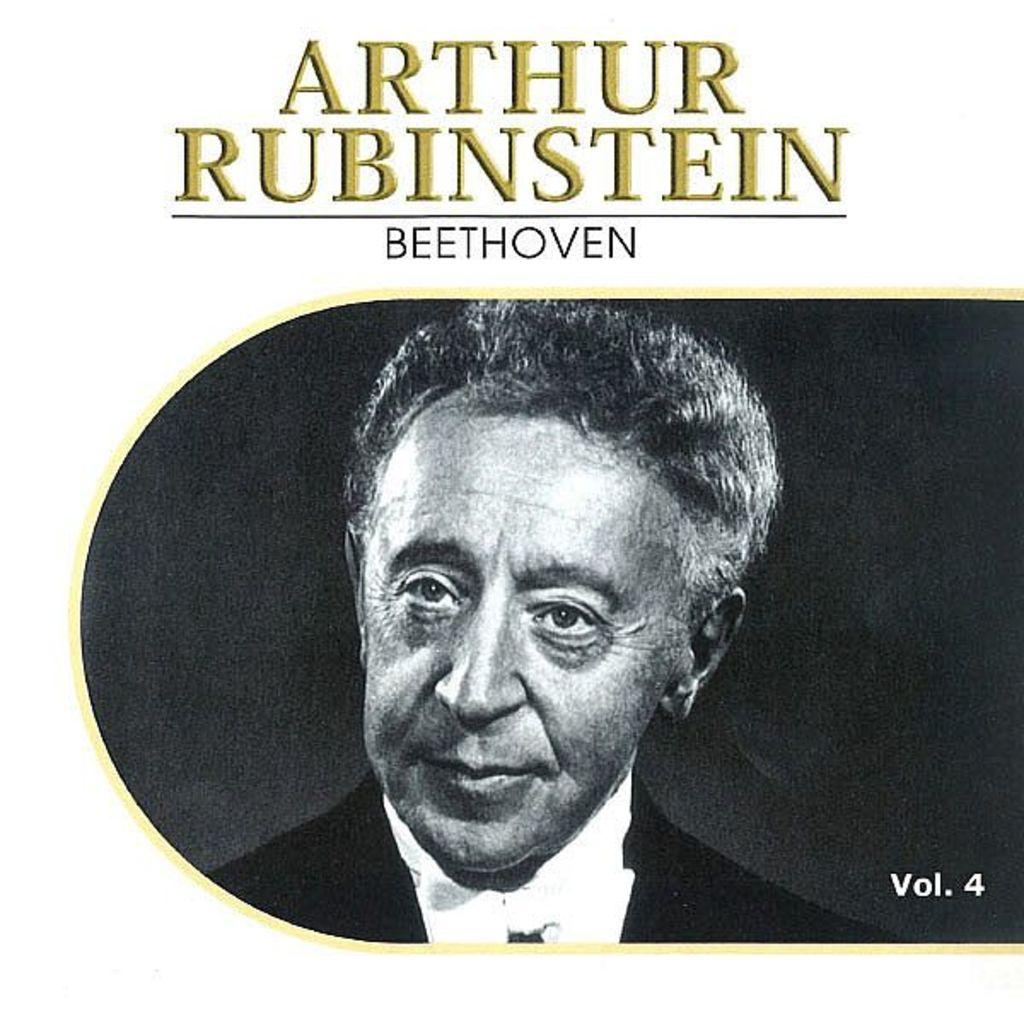What is present in the image? There is a poster in the image. What can be seen on the poster? The poster contains an image of a person. What type of locket is the person wearing in the image? There is no locket visible in the image; the poster only contains an image of a person. How many men are present in the image? There is only one person depicted in the image, and it is not specified whether the person is male or female. 